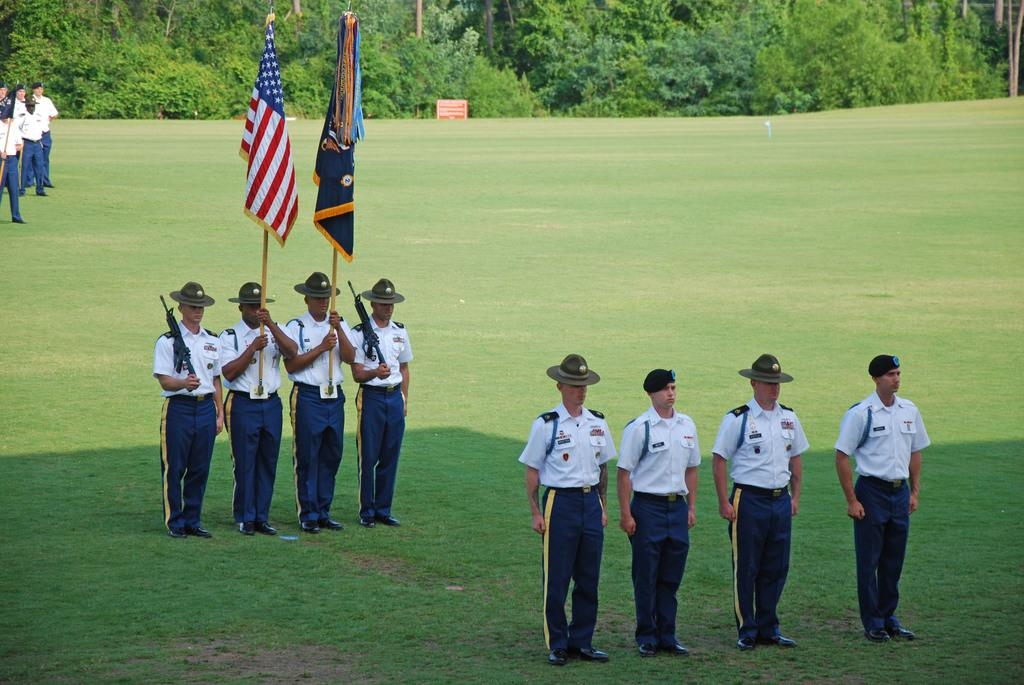What are the people in the image doing? The people in the image are on the grass. What are some of the people holding in the image? Some people are holding objects in the image. What type of headwear can be seen on some people in the image? Some people are wearing caps in the image. What can be seen in the background of the image? There are trees visible at the top of the image. What type of decorative items are present in the image? There are flags in the image. Can you tell me how many owls are sitting on the people's noses in the image? There are no owls present in the image, and therefore none are sitting on people's noses. 